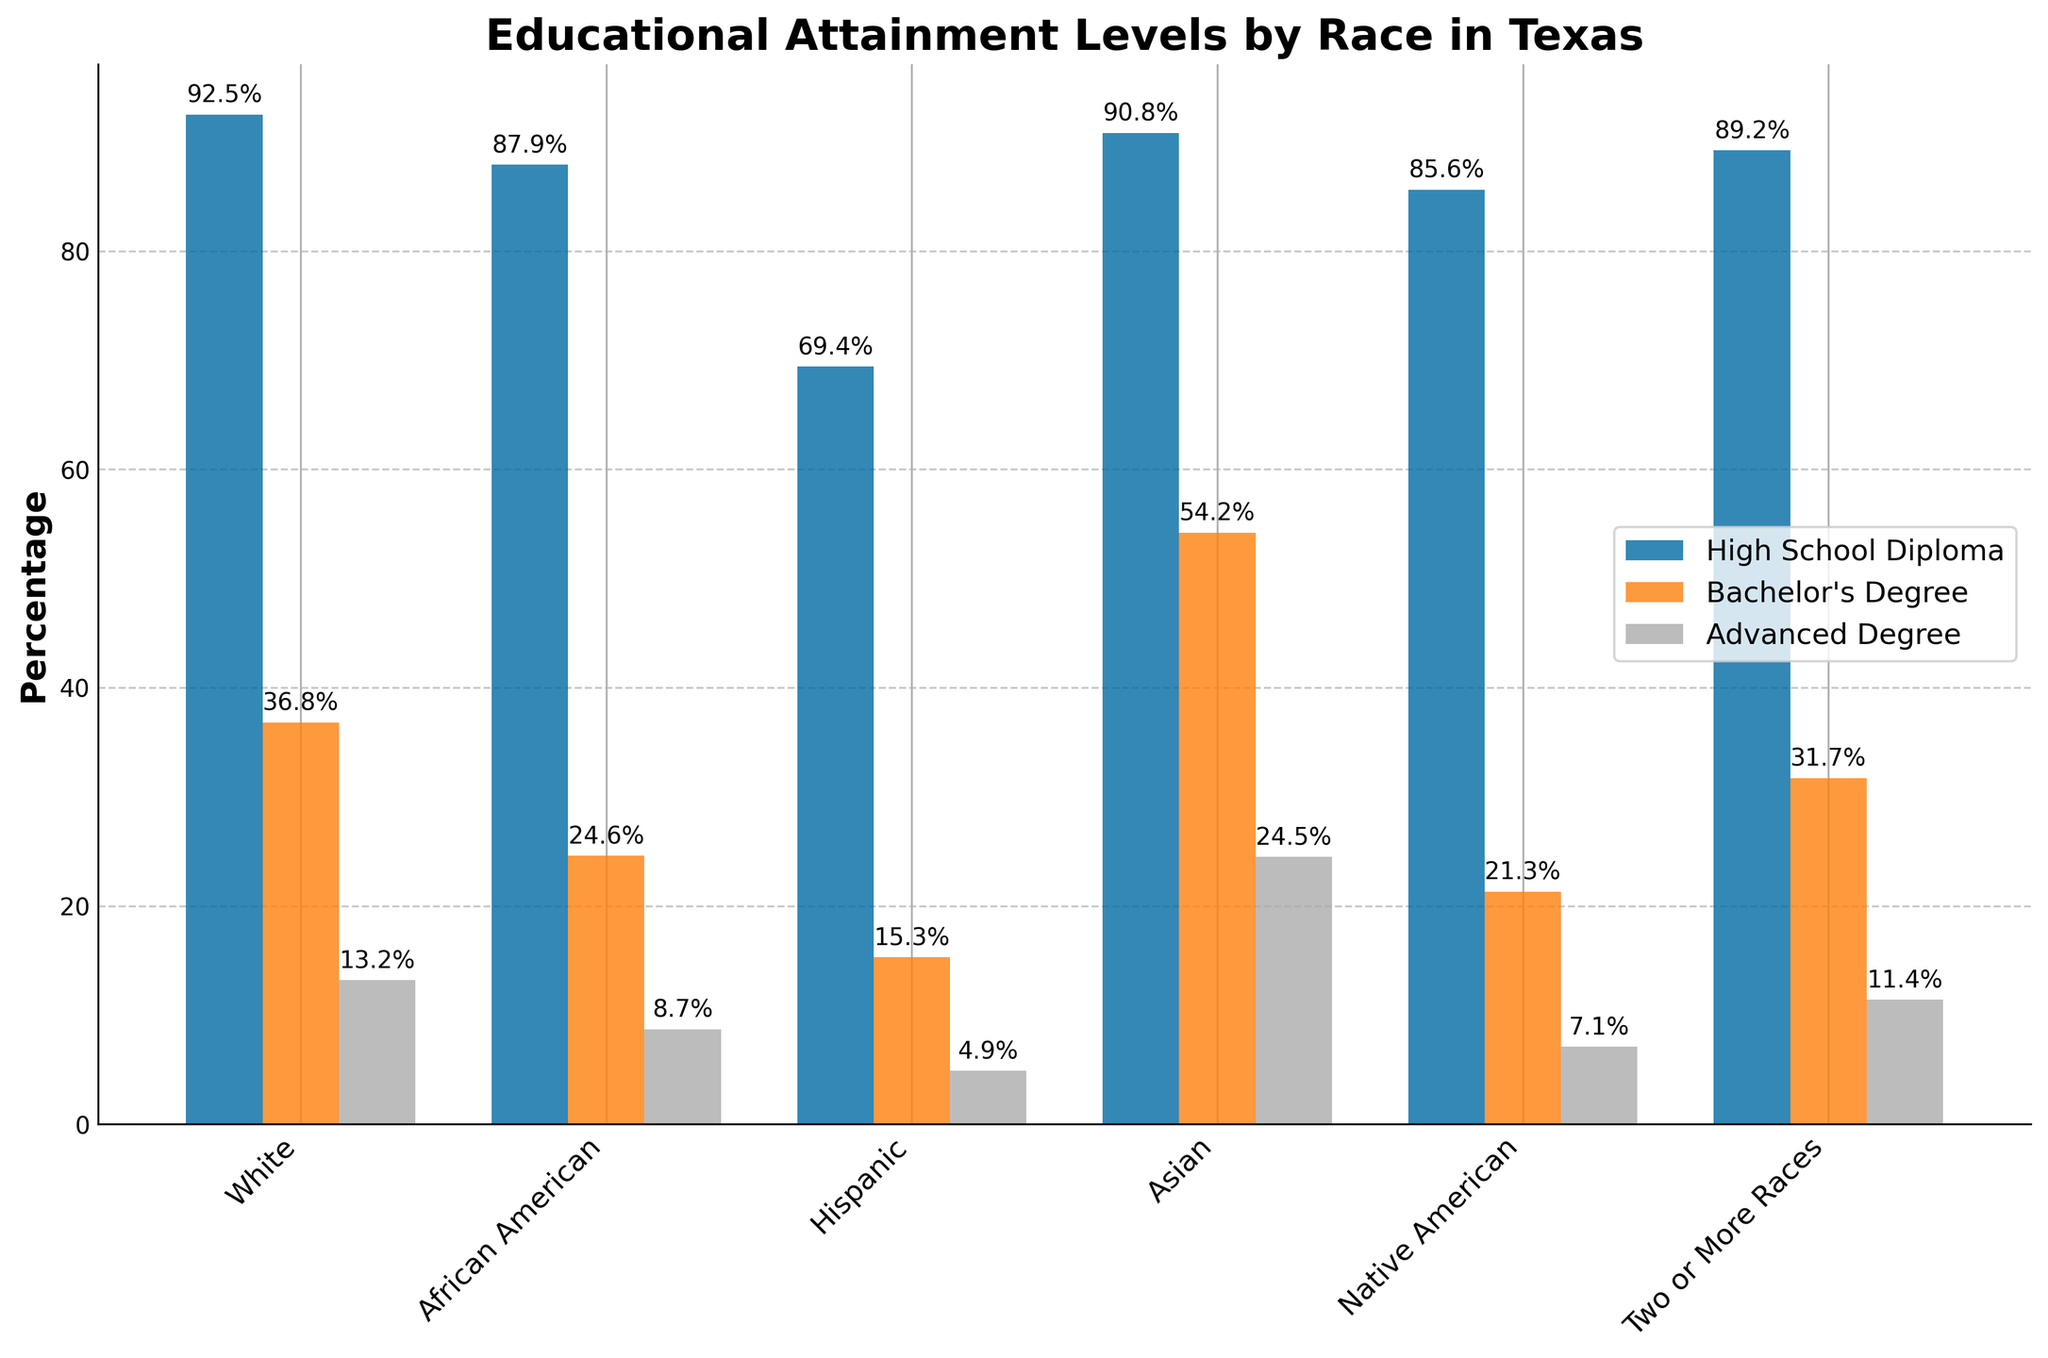What is the percentage of African Americans with a Bachelor's Degree in Texas? The graph shows the educational attainment levels of different racial groups in Texas. For African Americans, the bar for Bachelor's Degrees indicates a percentage of 24.6%.
Answer: 24.6% Which racial group has the highest percentage of individuals with an Advanced Degree? By comparing the heights of the bars representing Advanced Degrees for each racial group, it is evident that Asians have the tallest bar at 24.5%, indicating the highest percentage.
Answer: Asian How much higher is the percentage of Hispanics with a High School Diploma compared to an Advanced Degree? From the graph, the percentage of Hispanics with a High School Diploma is 69.4%, and the percentage with an Advanced Degree is 4.9%. The difference between these percentages is 69.4% - 4.9% = 64.5%.
Answer: 64.5% Which racial group has the smallest gap between the percentages of individuals with a High School Diploma and an Advanced Degree? To determine this, calculate the difference for each racial group. The smallest difference is for Asians, with a gap of 90.8% - 24.5% = 66.3%.
Answer: Asian By how many percentage points is the Advanced Degree attainment of Whites higher than that of African Americans? The data shows that 13.2% of Whites have an Advanced Degree compared to 8.7% of African Americans. The difference is 13.2% - 8.7% = 4.5%.
Answer: 4.5% Which racial group has the lowest percentage of individuals with a Bachelor's Degree? Observing the Bachelor's Degree bars, Hispanics have the shortest bar at 15.3%, indicating the lowest percentage.
Answer: Hispanic What is the average percentage of individuals with Bachelor's Degrees across all racial groups? To find the average, sum the percentages for all racial groups' Bachelor's Degrees and divide by the number of groups: (36.8 + 24.6 + 15.3 + 54.2 + 21.3 + 31.7) / 6 = 30.65%.
Answer: 30.65% How does the percentage of High School Diplomas for Native Americans compare to that for Two or More Races? The percentage of Native Americans with a High School Diploma is 85.6%, while for Two or More Races it is 89.2%. The difference is 89.2% - 85.6% = 3.6%, where Two or More Races is higher.
Answer: Two or More Races is 3.6% higher 